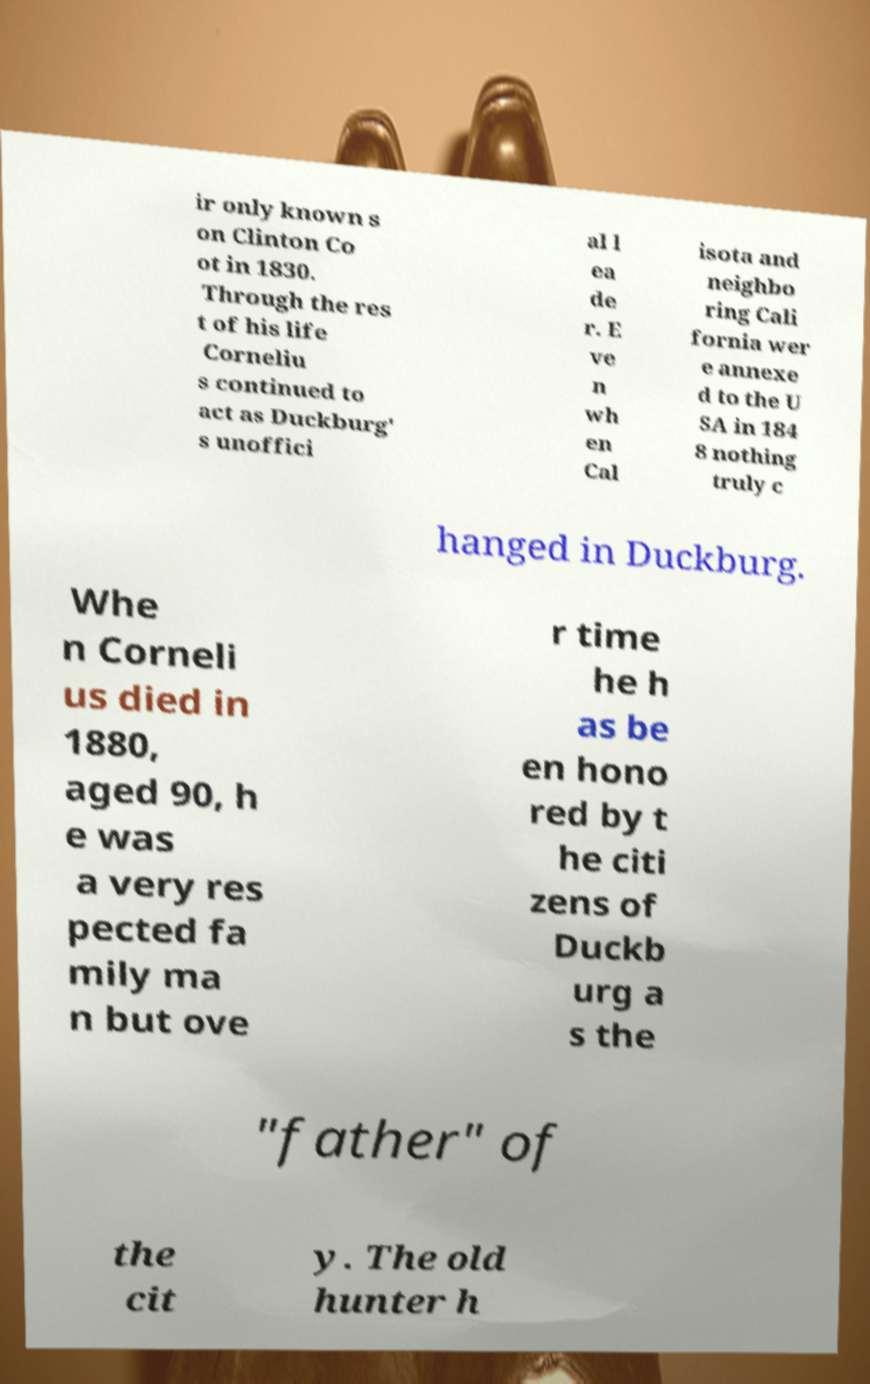What messages or text are displayed in this image? I need them in a readable, typed format. ir only known s on Clinton Co ot in 1830. Through the res t of his life Corneliu s continued to act as Duckburg' s unoffici al l ea de r. E ve n wh en Cal isota and neighbo ring Cali fornia wer e annexe d to the U SA in 184 8 nothing truly c hanged in Duckburg. Whe n Corneli us died in 1880, aged 90, h e was a very res pected fa mily ma n but ove r time he h as be en hono red by t he citi zens of Duckb urg a s the "father" of the cit y. The old hunter h 